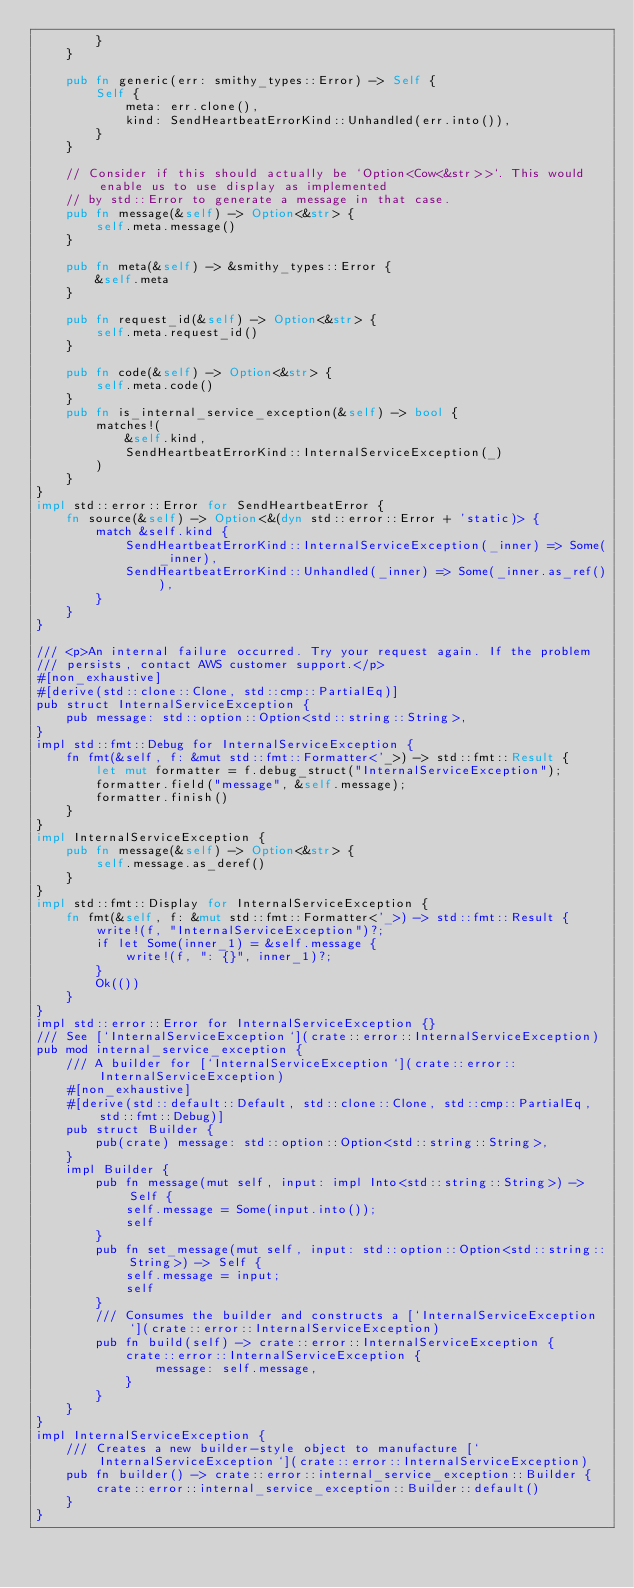Convert code to text. <code><loc_0><loc_0><loc_500><loc_500><_Rust_>        }
    }

    pub fn generic(err: smithy_types::Error) -> Self {
        Self {
            meta: err.clone(),
            kind: SendHeartbeatErrorKind::Unhandled(err.into()),
        }
    }

    // Consider if this should actually be `Option<Cow<&str>>`. This would enable us to use display as implemented
    // by std::Error to generate a message in that case.
    pub fn message(&self) -> Option<&str> {
        self.meta.message()
    }

    pub fn meta(&self) -> &smithy_types::Error {
        &self.meta
    }

    pub fn request_id(&self) -> Option<&str> {
        self.meta.request_id()
    }

    pub fn code(&self) -> Option<&str> {
        self.meta.code()
    }
    pub fn is_internal_service_exception(&self) -> bool {
        matches!(
            &self.kind,
            SendHeartbeatErrorKind::InternalServiceException(_)
        )
    }
}
impl std::error::Error for SendHeartbeatError {
    fn source(&self) -> Option<&(dyn std::error::Error + 'static)> {
        match &self.kind {
            SendHeartbeatErrorKind::InternalServiceException(_inner) => Some(_inner),
            SendHeartbeatErrorKind::Unhandled(_inner) => Some(_inner.as_ref()),
        }
    }
}

/// <p>An internal failure occurred. Try your request again. If the problem
/// persists, contact AWS customer support.</p>
#[non_exhaustive]
#[derive(std::clone::Clone, std::cmp::PartialEq)]
pub struct InternalServiceException {
    pub message: std::option::Option<std::string::String>,
}
impl std::fmt::Debug for InternalServiceException {
    fn fmt(&self, f: &mut std::fmt::Formatter<'_>) -> std::fmt::Result {
        let mut formatter = f.debug_struct("InternalServiceException");
        formatter.field("message", &self.message);
        formatter.finish()
    }
}
impl InternalServiceException {
    pub fn message(&self) -> Option<&str> {
        self.message.as_deref()
    }
}
impl std::fmt::Display for InternalServiceException {
    fn fmt(&self, f: &mut std::fmt::Formatter<'_>) -> std::fmt::Result {
        write!(f, "InternalServiceException")?;
        if let Some(inner_1) = &self.message {
            write!(f, ": {}", inner_1)?;
        }
        Ok(())
    }
}
impl std::error::Error for InternalServiceException {}
/// See [`InternalServiceException`](crate::error::InternalServiceException)
pub mod internal_service_exception {
    /// A builder for [`InternalServiceException`](crate::error::InternalServiceException)
    #[non_exhaustive]
    #[derive(std::default::Default, std::clone::Clone, std::cmp::PartialEq, std::fmt::Debug)]
    pub struct Builder {
        pub(crate) message: std::option::Option<std::string::String>,
    }
    impl Builder {
        pub fn message(mut self, input: impl Into<std::string::String>) -> Self {
            self.message = Some(input.into());
            self
        }
        pub fn set_message(mut self, input: std::option::Option<std::string::String>) -> Self {
            self.message = input;
            self
        }
        /// Consumes the builder and constructs a [`InternalServiceException`](crate::error::InternalServiceException)
        pub fn build(self) -> crate::error::InternalServiceException {
            crate::error::InternalServiceException {
                message: self.message,
            }
        }
    }
}
impl InternalServiceException {
    /// Creates a new builder-style object to manufacture [`InternalServiceException`](crate::error::InternalServiceException)
    pub fn builder() -> crate::error::internal_service_exception::Builder {
        crate::error::internal_service_exception::Builder::default()
    }
}
</code> 